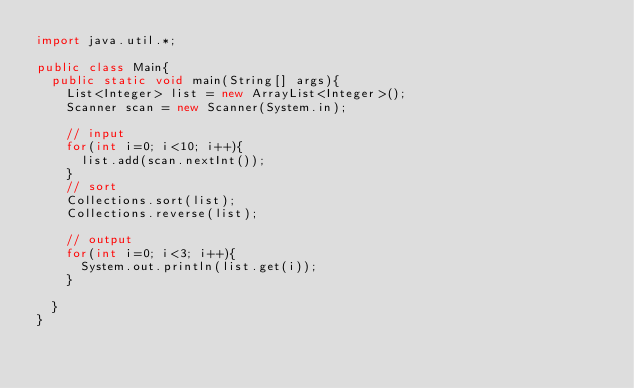Convert code to text. <code><loc_0><loc_0><loc_500><loc_500><_Java_>import java.util.*;

public class Main{
	public static void main(String[] args){
		List<Integer> list = new ArrayList<Integer>();
		Scanner scan = new Scanner(System.in);

		// input
		for(int i=0; i<10; i++){
			list.add(scan.nextInt());
		}
		// sort
		Collections.sort(list);
		Collections.reverse(list);

		// output
		for(int i=0; i<3; i++){
			System.out.println(list.get(i));
		}

	}
}</code> 